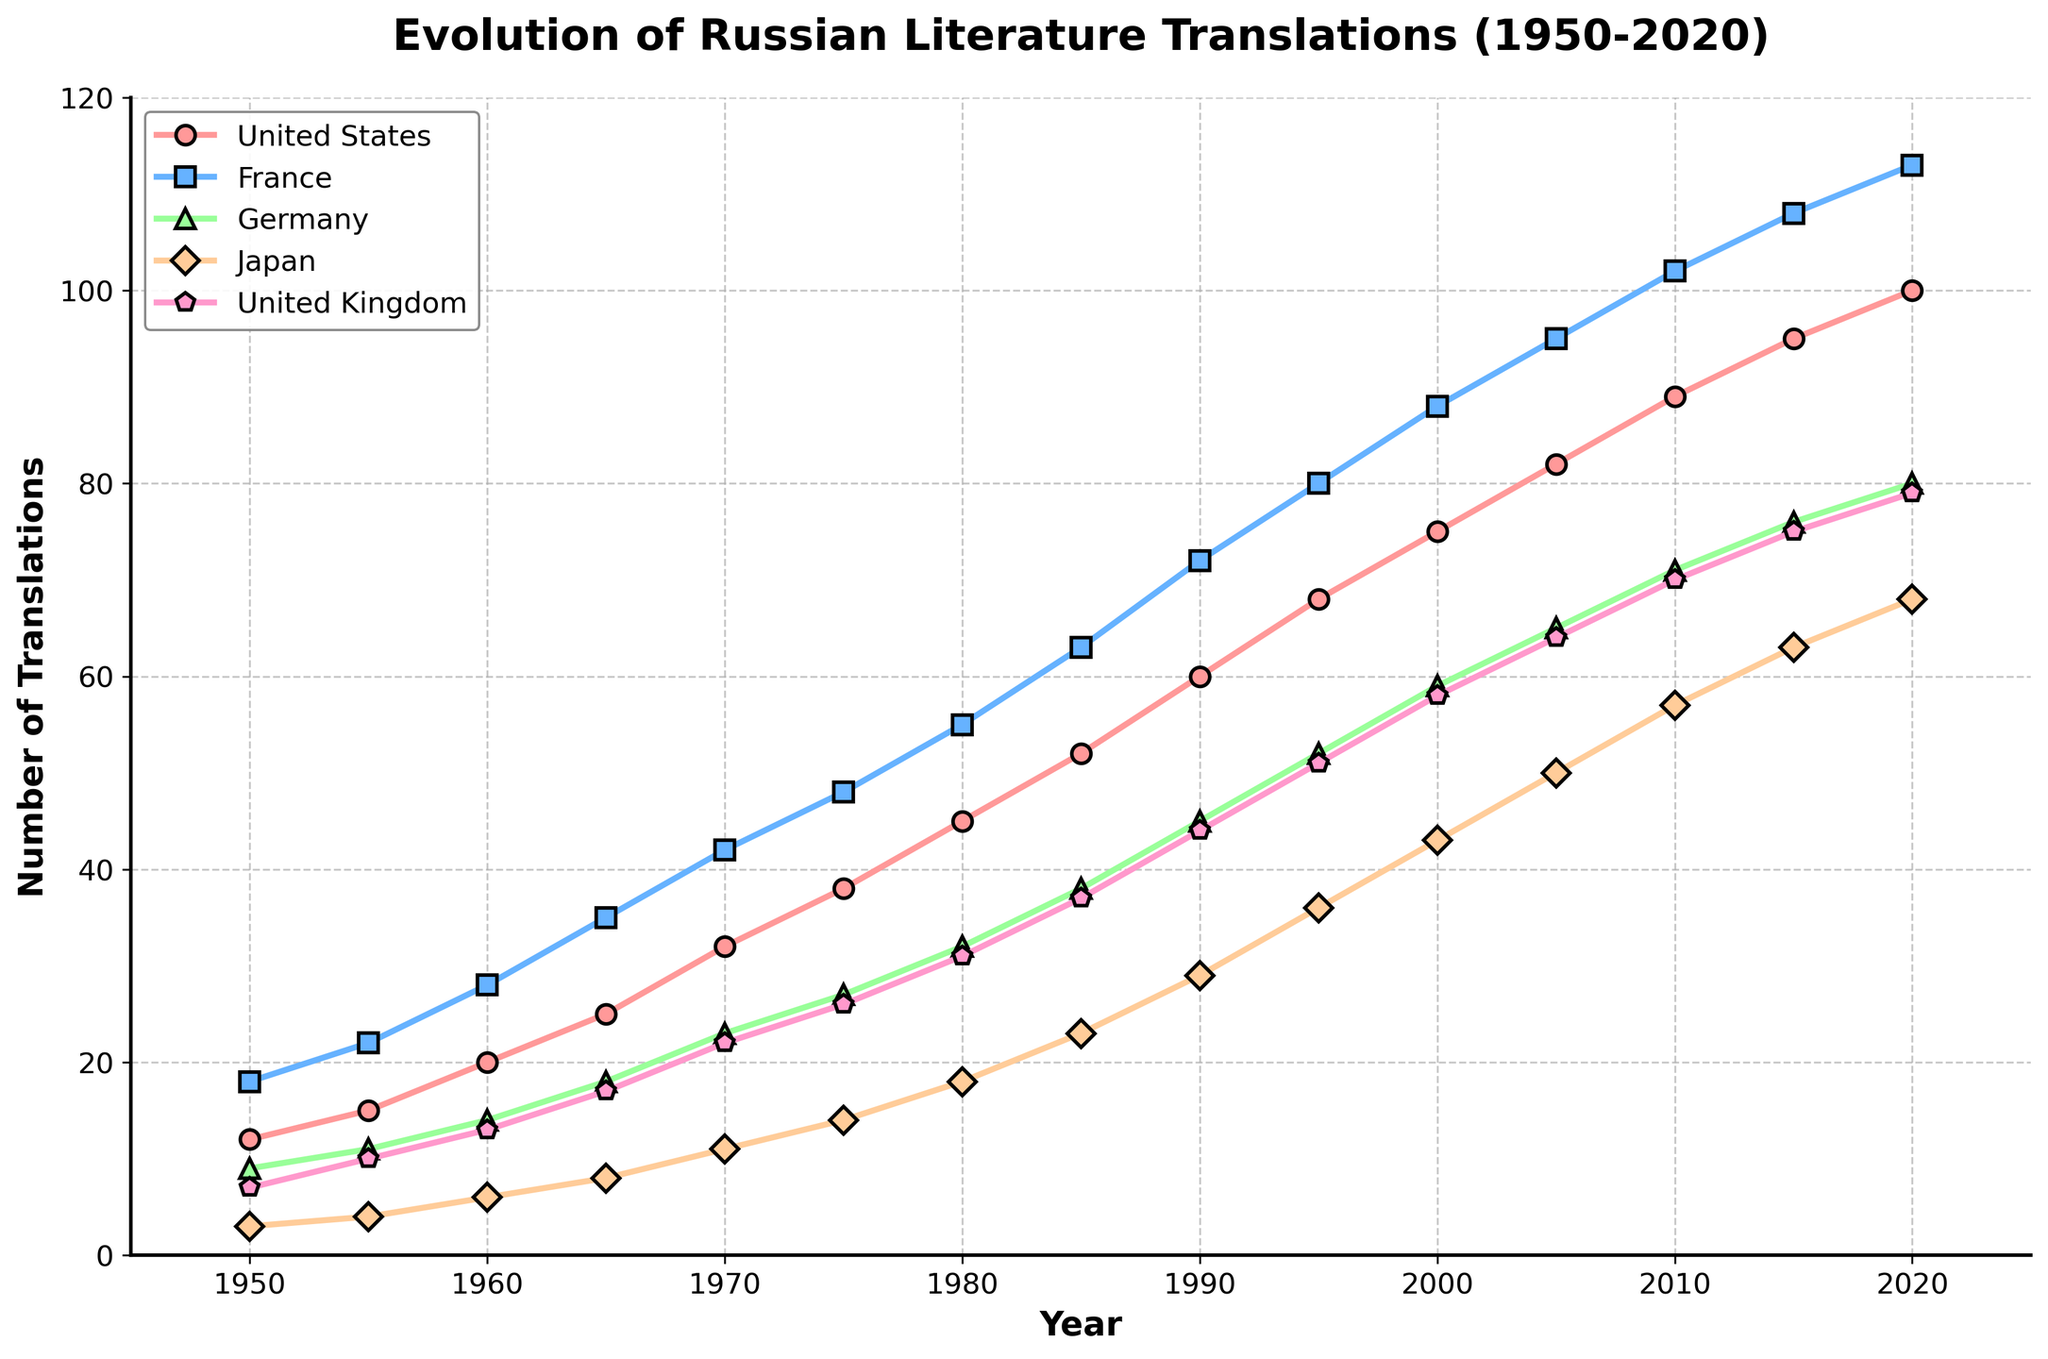What year did France first surpass 100 translations of Russian literature? By examining the plot for the line corresponding to France, we observe the point where it crosses 100 translations. This point is around the year 2010.
Answer: 2010 Between 1980 and 2000, which country showed the greatest increase in translations? First, for each country, calculate the difference in translations between 1980 and 2000. For the United States, the increase is 75 - 45 = 30; for France, 88 - 55 = 33; for Germany, 59 - 32 = 27; for Japan, 43 - 18 = 25; for the United Kingdom, 58 - 31 = 27. Comparing these differences, France shows the greatest increase of 33 translations.
Answer: France Which country had the lowest number of translations in 1970 and how many were there? Look at the data for the year 1970 across all countries. The values are United States: 32, France: 42, Germany: 23, Japan: 11, United Kingdom: 22. Japan, with 11 translations, has the lowest number.
Answer: Japan with 11 translations What is the average number of translations in the United Kingdom for the years 1950, 1970, and 1990? Calculate the sum of the translations in the United Kingdom during these years and divide by 3. (7 + 22 + 44) / 3 = 73 / 3 ≈ 24.33
Answer: 24.33 In what year did Germany surpass Japan in the number of translations for the first time? By examining the plot, find the intersection point of the lines representing Germany and Japan. This intersection is around the year 1960.
Answer: 1960 Between 1950 and 2020, which country had the most consistent increase in the number of translations? Analyze the trend lines for each country. The line for the United States appears to have the most linear and consistent increase over the years.
Answer: United States How many total translations of Russian literature were published in 1985 across all five countries? Sum the translations for each country in 1985: 52 (US) + 63 (France) + 38 (Germany) + 23 (Japan) + 37 (UK) = 213
Answer: 213 Which country represented by a line with a diamond marker shape had the least number of translations in 2000? Identify the diamond marker shape in the legend, which corresponds to Japan. The number of translations for Japan in 2000 is 43.
Answer: Japan What is the difference in the number of translations between Germany and the United Kingdom in 2010? Subtract the number of translations for the United Kingdom from that of Germany in 2010: 71 (Germany) - 70 (United Kingdom) = 1
Answer: 1 In which year did the number of translations in France and the United States become closest to each other, and what were those numbers? Find where the France and the United States lines converge most closely. Around the year 2020, their values are 100 (United States) and 113 (France), with a difference of 13, which is the smallest gap in recent years.
Answer: 2020, 100 (US) and 113 (France) 